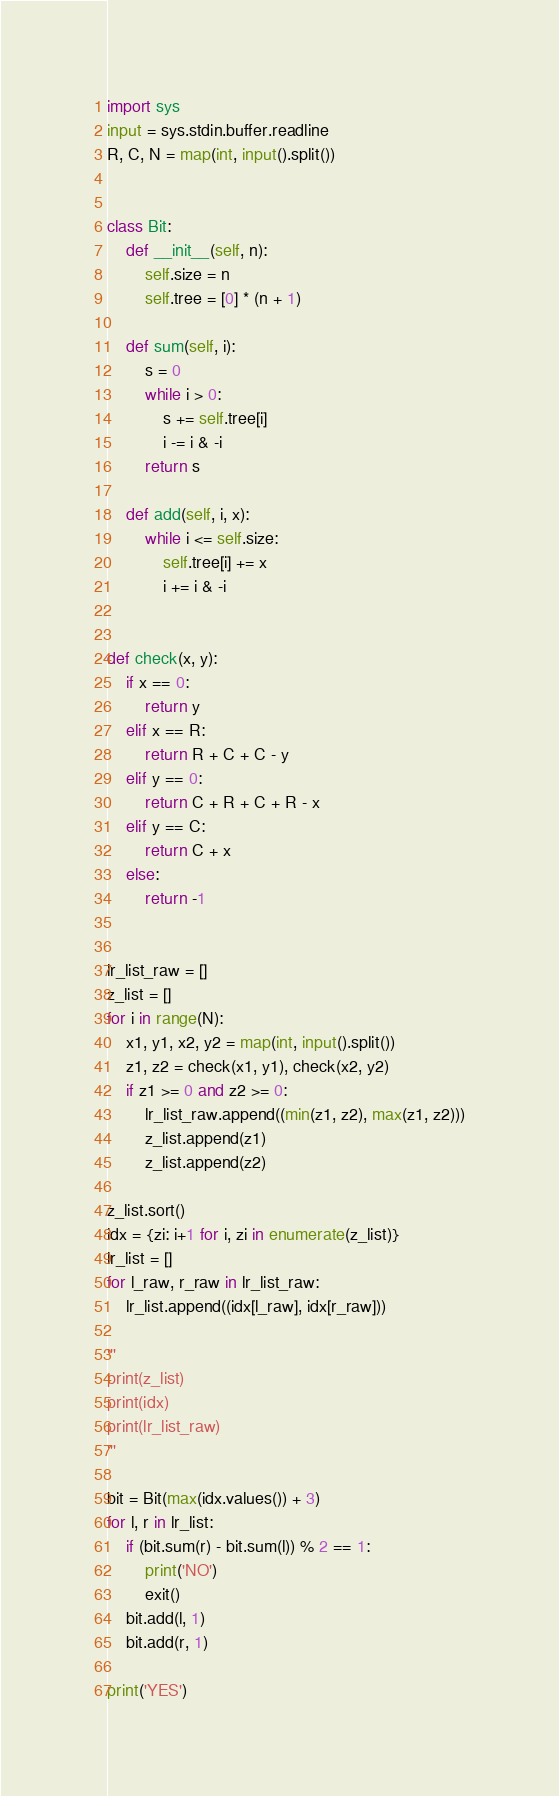<code> <loc_0><loc_0><loc_500><loc_500><_Python_>import sys
input = sys.stdin.buffer.readline
R, C, N = map(int, input().split())


class Bit:
    def __init__(self, n):
        self.size = n
        self.tree = [0] * (n + 1)

    def sum(self, i):
        s = 0
        while i > 0:
            s += self.tree[i]
            i -= i & -i
        return s

    def add(self, i, x):
        while i <= self.size:
            self.tree[i] += x
            i += i & -i


def check(x, y):
    if x == 0:
        return y
    elif x == R:
        return R + C + C - y
    elif y == 0:
        return C + R + C + R - x
    elif y == C:
        return C + x
    else:
        return -1


lr_list_raw = []
z_list = []
for i in range(N):
    x1, y1, x2, y2 = map(int, input().split())
    z1, z2 = check(x1, y1), check(x2, y2)
    if z1 >= 0 and z2 >= 0:
        lr_list_raw.append((min(z1, z2), max(z1, z2)))
        z_list.append(z1)
        z_list.append(z2)

z_list.sort()
idx = {zi: i+1 for i, zi in enumerate(z_list)}
lr_list = []
for l_raw, r_raw in lr_list_raw:
    lr_list.append((idx[l_raw], idx[r_raw]))

'''
print(z_list)
print(idx)
print(lr_list_raw)
'''

bit = Bit(max(idx.values()) + 3)
for l, r in lr_list:
    if (bit.sum(r) - bit.sum(l)) % 2 == 1:
        print('NO')
        exit()
    bit.add(l, 1)
    bit.add(r, 1)

print('YES')
</code> 